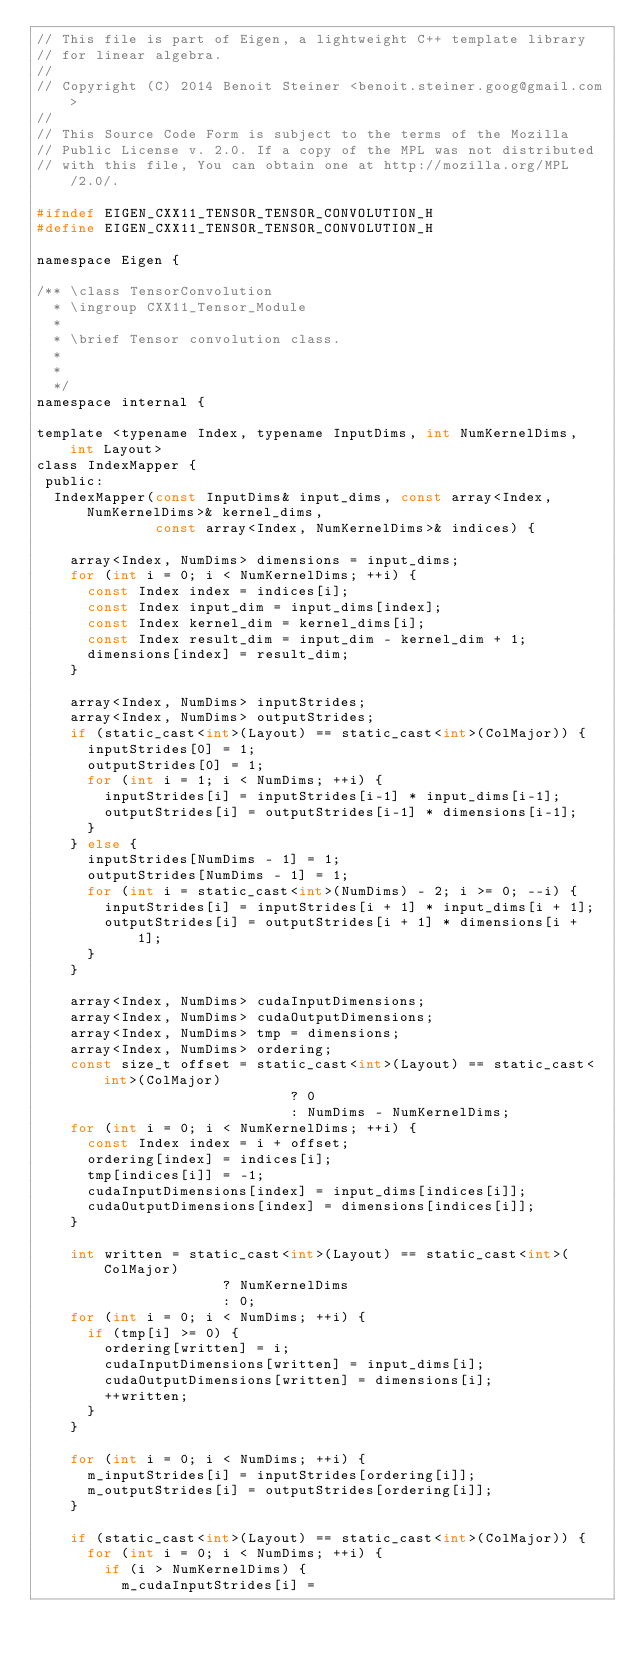<code> <loc_0><loc_0><loc_500><loc_500><_C_>// This file is part of Eigen, a lightweight C++ template library
// for linear algebra.
//
// Copyright (C) 2014 Benoit Steiner <benoit.steiner.goog@gmail.com>
//
// This Source Code Form is subject to the terms of the Mozilla
// Public License v. 2.0. If a copy of the MPL was not distributed
// with this file, You can obtain one at http://mozilla.org/MPL/2.0/.

#ifndef EIGEN_CXX11_TENSOR_TENSOR_CONVOLUTION_H
#define EIGEN_CXX11_TENSOR_TENSOR_CONVOLUTION_H

namespace Eigen {

/** \class TensorConvolution
  * \ingroup CXX11_Tensor_Module
  *
  * \brief Tensor convolution class.
  *
  *
  */
namespace internal {

template <typename Index, typename InputDims, int NumKernelDims, int Layout>
class IndexMapper {
 public:
  IndexMapper(const InputDims& input_dims, const array<Index, NumKernelDims>& kernel_dims,
              const array<Index, NumKernelDims>& indices) {

    array<Index, NumDims> dimensions = input_dims;
    for (int i = 0; i < NumKernelDims; ++i) {
      const Index index = indices[i];
      const Index input_dim = input_dims[index];
      const Index kernel_dim = kernel_dims[i];
      const Index result_dim = input_dim - kernel_dim + 1;
      dimensions[index] = result_dim;
    }

    array<Index, NumDims> inputStrides;
    array<Index, NumDims> outputStrides;
    if (static_cast<int>(Layout) == static_cast<int>(ColMajor)) {
      inputStrides[0] = 1;
      outputStrides[0] = 1;
      for (int i = 1; i < NumDims; ++i) {
        inputStrides[i] = inputStrides[i-1] * input_dims[i-1];
        outputStrides[i] = outputStrides[i-1] * dimensions[i-1];
      }
    } else {
      inputStrides[NumDims - 1] = 1;
      outputStrides[NumDims - 1] = 1;
      for (int i = static_cast<int>(NumDims) - 2; i >= 0; --i) {
        inputStrides[i] = inputStrides[i + 1] * input_dims[i + 1];
        outputStrides[i] = outputStrides[i + 1] * dimensions[i + 1];
      }
    }

    array<Index, NumDims> cudaInputDimensions;
    array<Index, NumDims> cudaOutputDimensions;
    array<Index, NumDims> tmp = dimensions;
    array<Index, NumDims> ordering;
    const size_t offset = static_cast<int>(Layout) == static_cast<int>(ColMajor)
                              ? 0
                              : NumDims - NumKernelDims;
    for (int i = 0; i < NumKernelDims; ++i) {
      const Index index = i + offset;
      ordering[index] = indices[i];
      tmp[indices[i]] = -1;
      cudaInputDimensions[index] = input_dims[indices[i]];
      cudaOutputDimensions[index] = dimensions[indices[i]];
    }

    int written = static_cast<int>(Layout) == static_cast<int>(ColMajor)
                      ? NumKernelDims
                      : 0;
    for (int i = 0; i < NumDims; ++i) {
      if (tmp[i] >= 0) {
        ordering[written] = i;
        cudaInputDimensions[written] = input_dims[i];
        cudaOutputDimensions[written] = dimensions[i];
        ++written;
      }
    }

    for (int i = 0; i < NumDims; ++i) {
      m_inputStrides[i] = inputStrides[ordering[i]];
      m_outputStrides[i] = outputStrides[ordering[i]];
    }

    if (static_cast<int>(Layout) == static_cast<int>(ColMajor)) {
      for (int i = 0; i < NumDims; ++i) {
        if (i > NumKernelDims) {
          m_cudaInputStrides[i] =</code> 